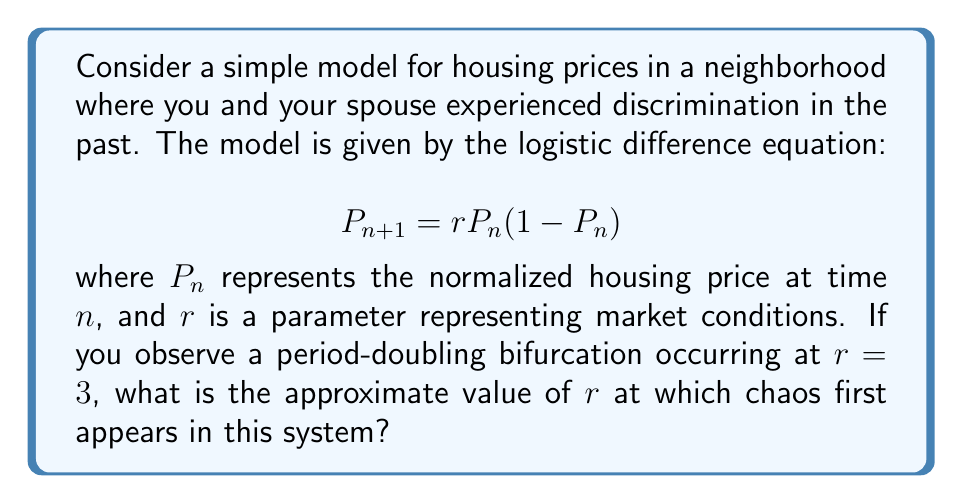Help me with this question. To solve this problem, we'll follow these steps:

1) In a logistic map, period-doubling bifurcations occur as the parameter $r$ increases.

2) The first period-doubling bifurcation occurs at $r = 3$, as stated in the question.

3) Subsequent period-doubling bifurcations occur at shorter intervals, following a geometric sequence.

4) The ratio between successive bifurcation intervals converges to the Feigenbaum constant, δ ≈ 4.669201...

5) We can use this to estimate the onset of chaos. If we denote the $r$-value for the $n$-th bifurcation as $r_n$, then:

   $$\lim_{n \to \infty} \frac{r_n - r_{n-1}}{r_{n+1} - r_n} = \delta$$

6) The onset of chaos occurs at the accumulation point of these bifurcations, which we can estimate as:

   $$r_{\infty} \approx r_0 + \frac{r_1 - r_0}{\delta - 1}$$

   where $r_0 = 3$ (first bifurcation) and $r_1 \approx 3.45$ (second bifurcation, approximated)

7) Substituting these values:

   $$r_{\infty} \approx 3 + \frac{3.45 - 3}{4.669201 - 1} \approx 3.57$$

Therefore, chaos first appears in this system when $r$ is approximately 3.57.
Answer: $r \approx 3.57$ 